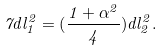Convert formula to latex. <formula><loc_0><loc_0><loc_500><loc_500>7 d l _ { 1 } ^ { 2 } = ( \frac { 1 + \alpha ^ { 2 } } { 4 } ) d l _ { 2 } ^ { 2 } .</formula> 